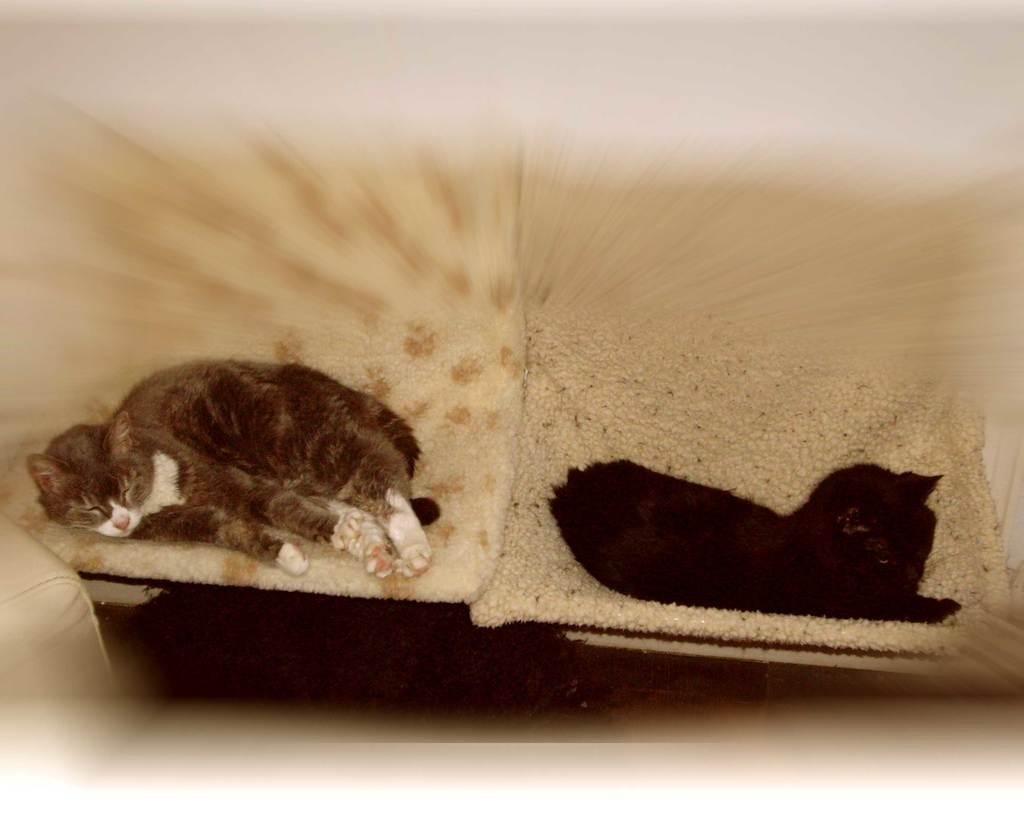How many cats are in the image? There are two cats in the image. What are the cats doing in the image? The cats are laying on a sofa. Can you describe the background of the image? The background of the image is blurry. What type of thing are the cats playing with in the image? There are no visible objects in the image that the cats could be playing with. 